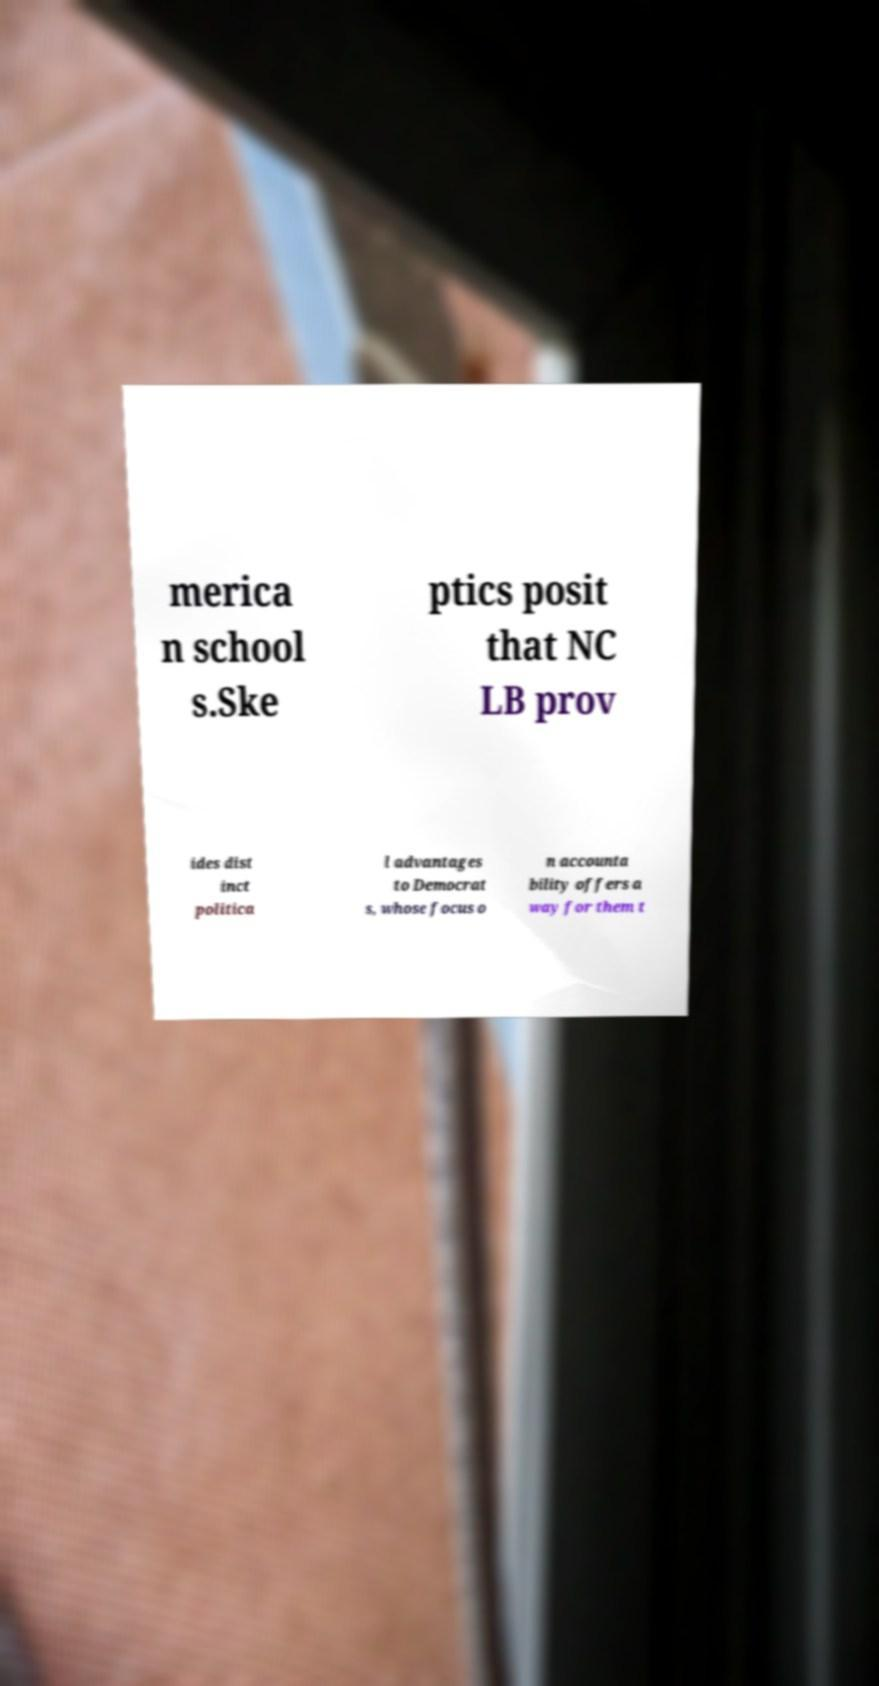I need the written content from this picture converted into text. Can you do that? merica n school s.Ske ptics posit that NC LB prov ides dist inct politica l advantages to Democrat s, whose focus o n accounta bility offers a way for them t 